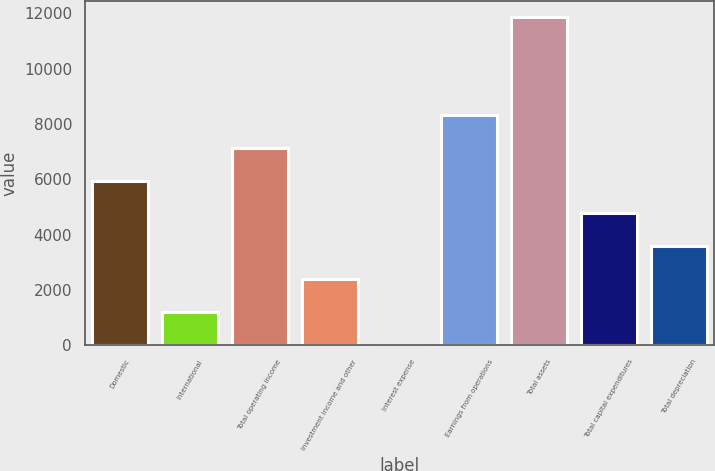<chart> <loc_0><loc_0><loc_500><loc_500><bar_chart><fcel>Domestic<fcel>International<fcel>Total operating income<fcel>Investment income and other<fcel>Interest expense<fcel>Earnings from operations<fcel>Total assets<fcel>Total capital expenditures<fcel>Total depreciation<nl><fcel>5947<fcel>1213.4<fcel>7130.4<fcel>2396.8<fcel>30<fcel>8313.8<fcel>11864<fcel>4763.6<fcel>3580.2<nl></chart> 